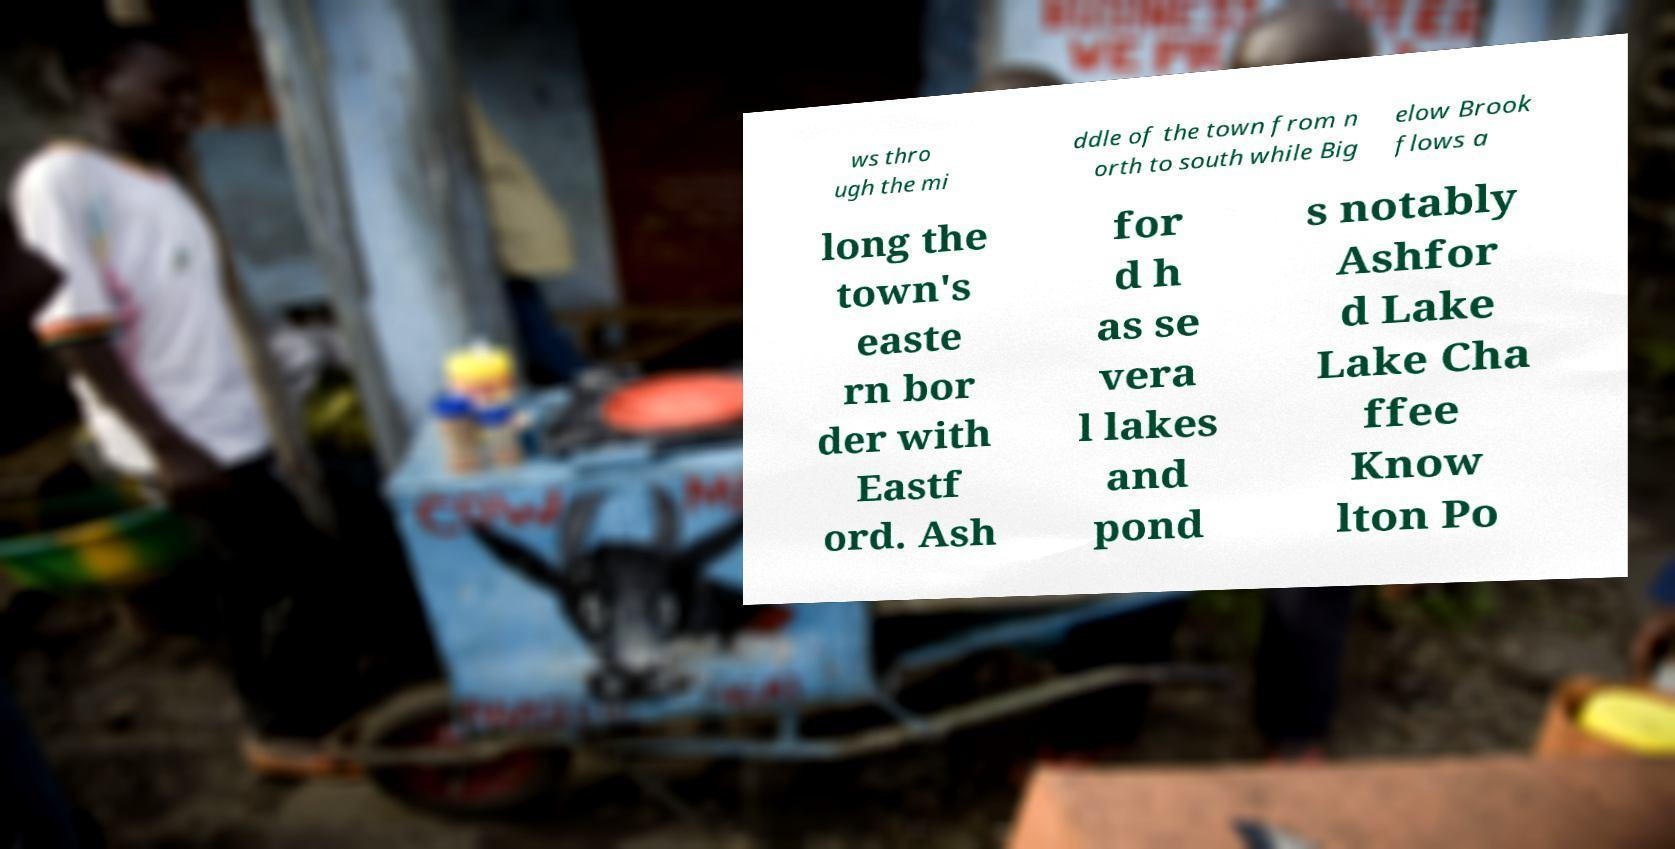Can you read and provide the text displayed in the image?This photo seems to have some interesting text. Can you extract and type it out for me? ws thro ugh the mi ddle of the town from n orth to south while Big elow Brook flows a long the town's easte rn bor der with Eastf ord. Ash for d h as se vera l lakes and pond s notably Ashfor d Lake Lake Cha ffee Know lton Po 